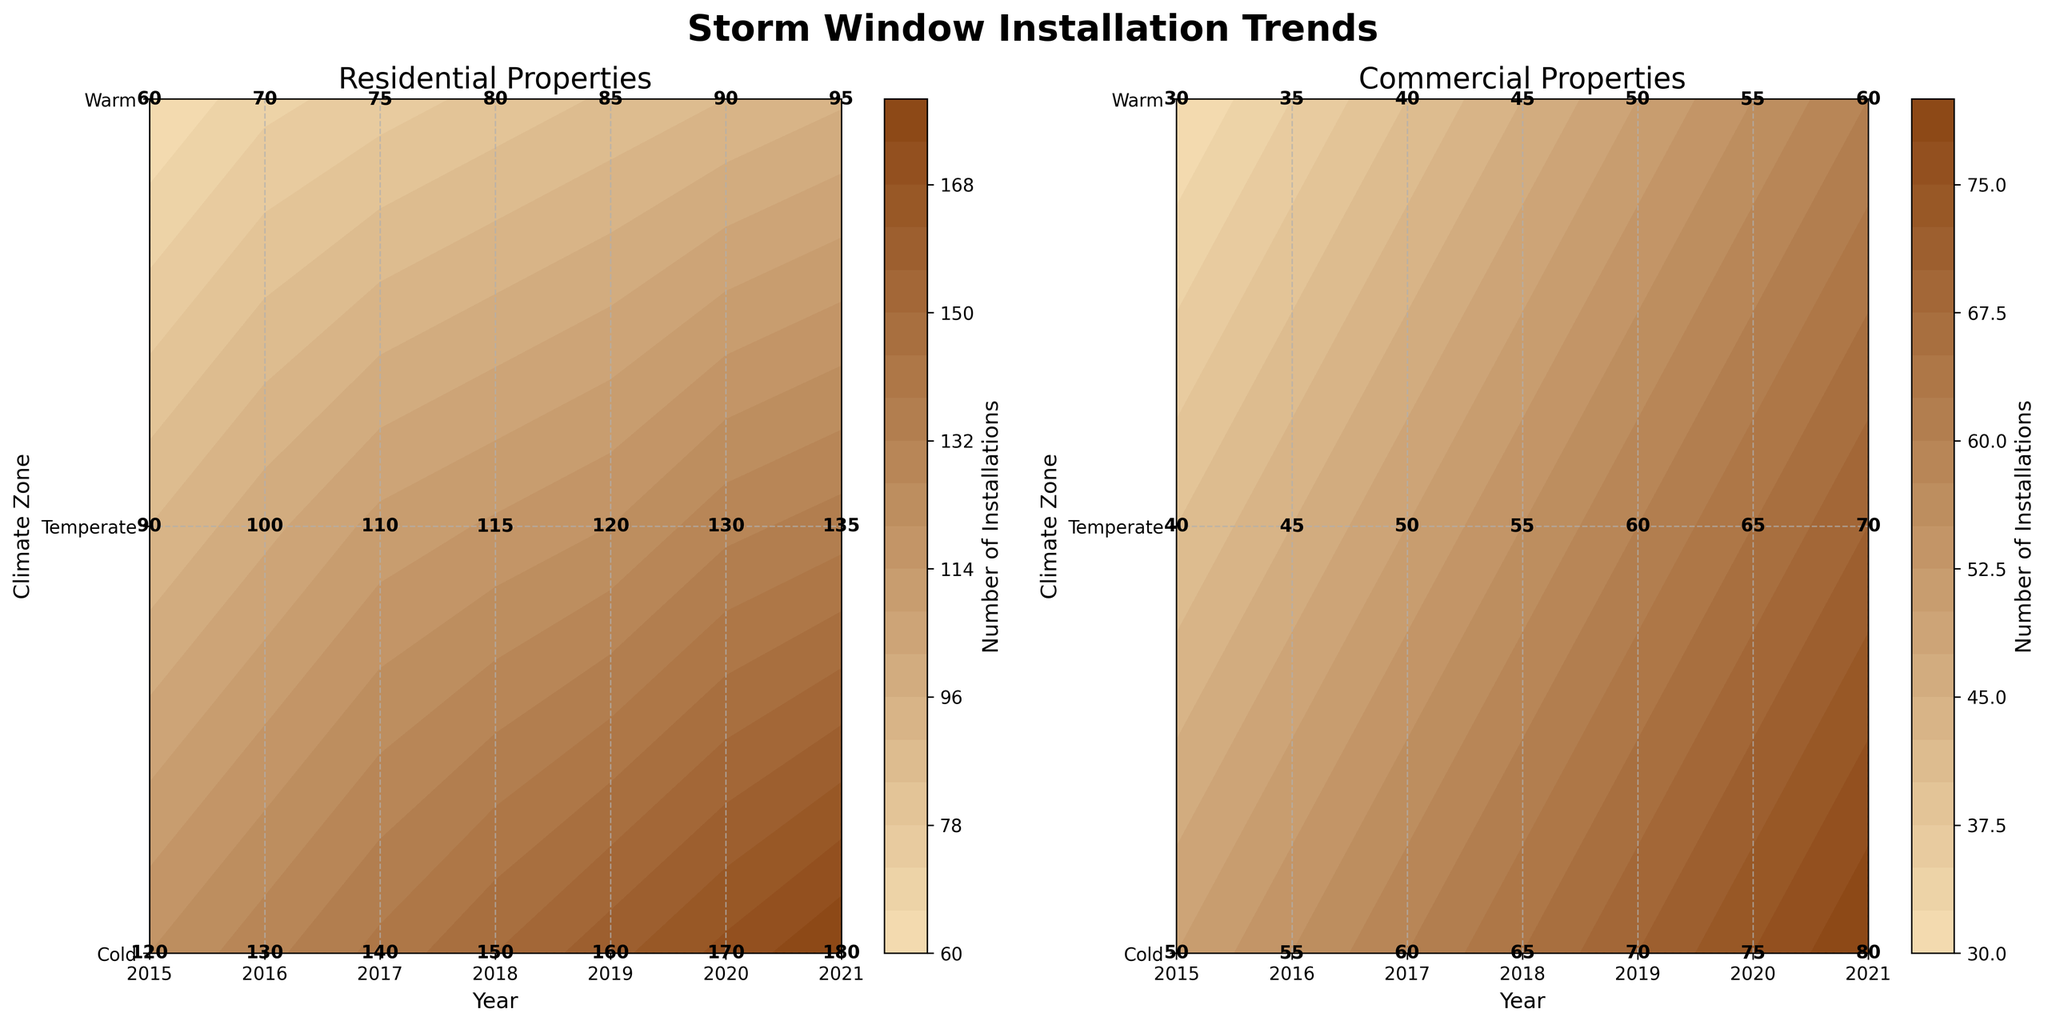what is the title of the figure? The figure title is located at the top of the figure. It states "Storm Window Installation Trends".
Answer: Storm Window Installation Trends How many subplots are there? There are two subplots side by side in the figure. This can be identified by the two separate sets of data visualizations with distinct titles.
Answer: 2 What does the color intensity represent in the figure? The color intensity gradient in the contour plot indicates the number of installations, where lighter colors represent fewer installations and darker colors represent more installations.
Answer: Number of installations Which property type had the highest installations in the Cold climate zone in 2020? Look at the contour plot for Residential and Commercial properties under the column for 2020. The Residential subplot has a darker color in the Cold climate zone for 2020 compared to Commercial.
Answer: Residential By how much did the number of installations increase in the Cold climate zone for Commercial properties from 2015 to 2021? Observe the number of installations in the Cold climate zone for Commercial properties for the years 2015 and 2021. The values are 50 in 2015 and 80 in 2021. The increase is 80 - 50 = 30.
Answer: 30 Which year had the highest number of installations for Residential properties in the Temperate climate zone? Look at the contour plot for Residential properties in the Temperate climate zone and identify the darkest color. The darkest color appears under the 2021 label.
Answer: 2021 Compare the trend of installations for Residential properties in the Warm climate zone to Commercial properties in the same zone. Which experienced a more steady increase? Review the contour plots for both Residential and Commercial properties in the Warm zone from 2015 to 2021. The Residential properties show a steadier increase compared to Commercial properties.
Answer: Residential What was the total number of installations for Commercial properties in the Cold climate zone over all the years? Sum the values for Commercial properties in the Cold climate zone from 2015 to 2021. The values are 50, 55, 60, 65, 70, 75, and 80. The total is 50+55+60+65+70+75+80 = 455.
Answer: 455 Which property type shows a greater difference in installations between the Cold and Warm climate zones in 2021? Compare the number of installations in 2021 for Residential and Commercial properties in both the Cold and Warm climate zones. Residential properties have 180 installations in Cold and 95 in Warm (180-95=85). Commercial properties have 80 in Cold and 60 in Warm (80-60=20). The greater difference is in Residential properties.
Answer: Residential In which combination of property type and climate zone were the lowest installations observed in 2018? Identify the combination with the lightest color in 2018 in the contour plots. The lowest installations in 2018 were for Commercial properties in the Warm climate zone.
Answer: Commercial properties in the Warm climate zone 